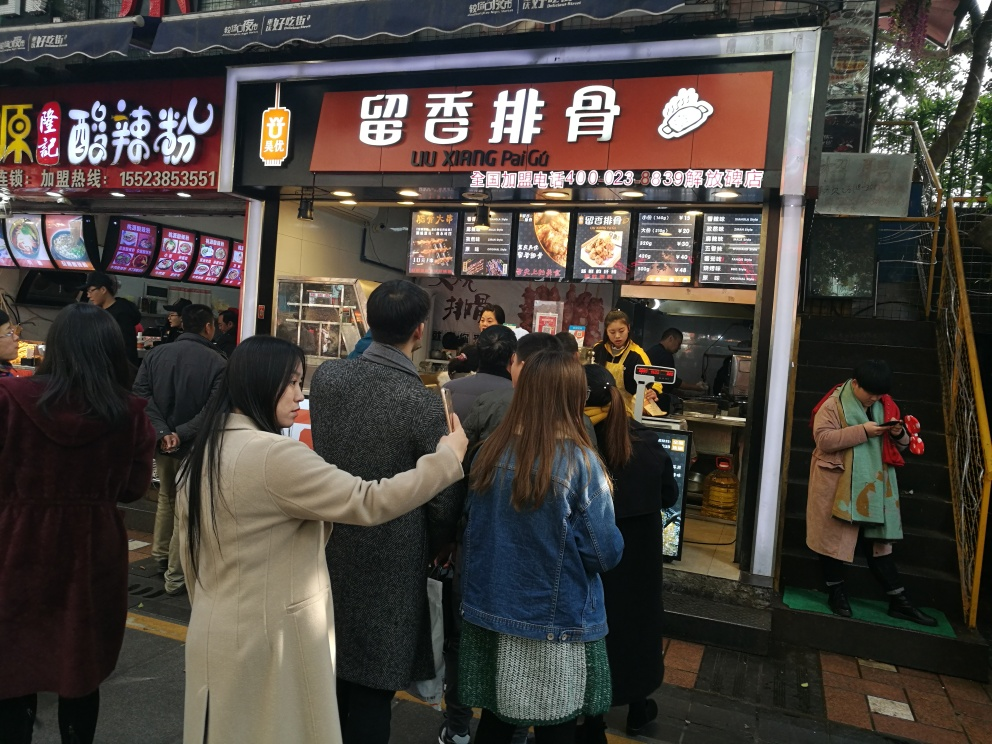What is the general atmosphere of the place shown in the image? The atmosphere of the place in the image is lively and bustling. It shows a busy street food stall with many people waiting in line or walking by. This suggests a popular eating spot, likely characterized by a fast-paced environment and the engaging aromas of freshly cooked street food. Do the people look like they are enjoying themselves? Yes, the people in the image appear to be enjoying the environment. Although the scene is busy, individuals look engaged and interested, either in conversation or in anticipation of their food. Such environments typically generate a positive vibe, part of the appeal of street food locales. 